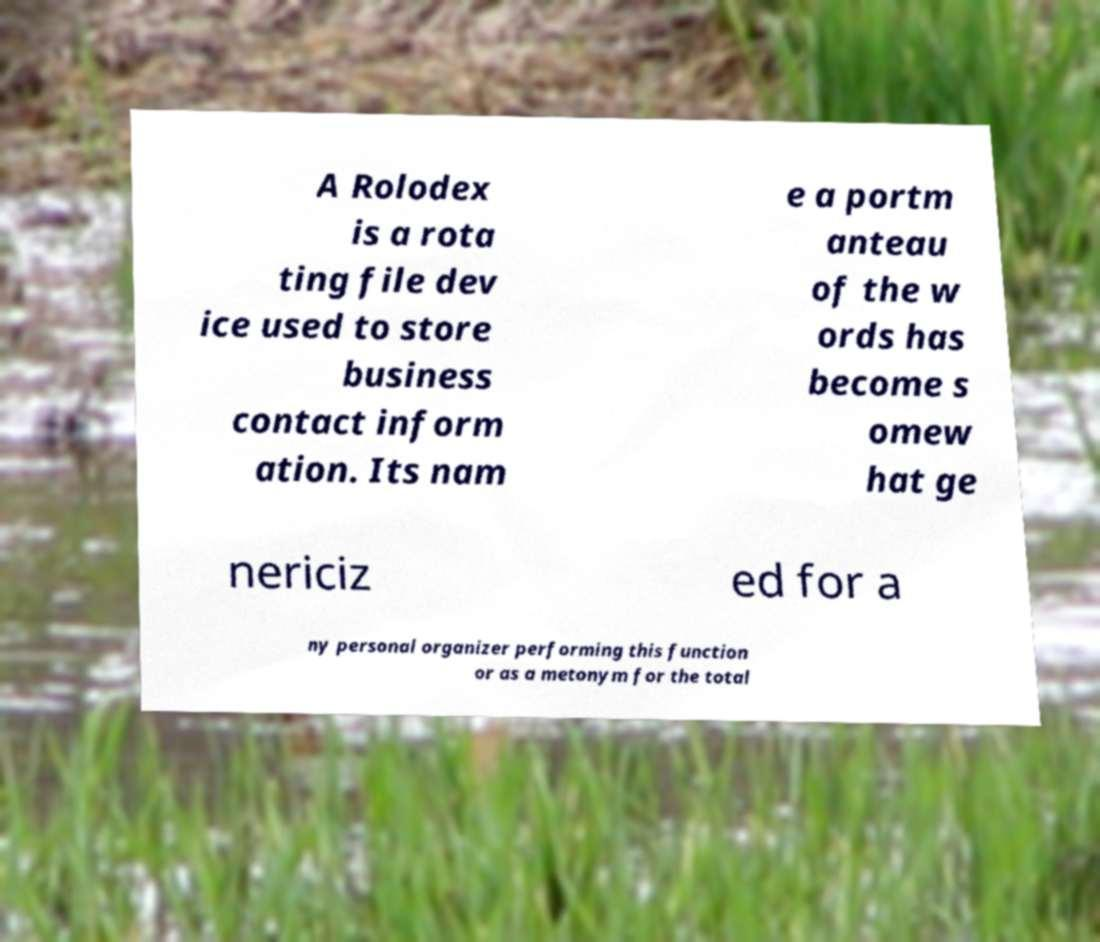Please read and relay the text visible in this image. What does it say? A Rolodex is a rota ting file dev ice used to store business contact inform ation. Its nam e a portm anteau of the w ords has become s omew hat ge nericiz ed for a ny personal organizer performing this function or as a metonym for the total 